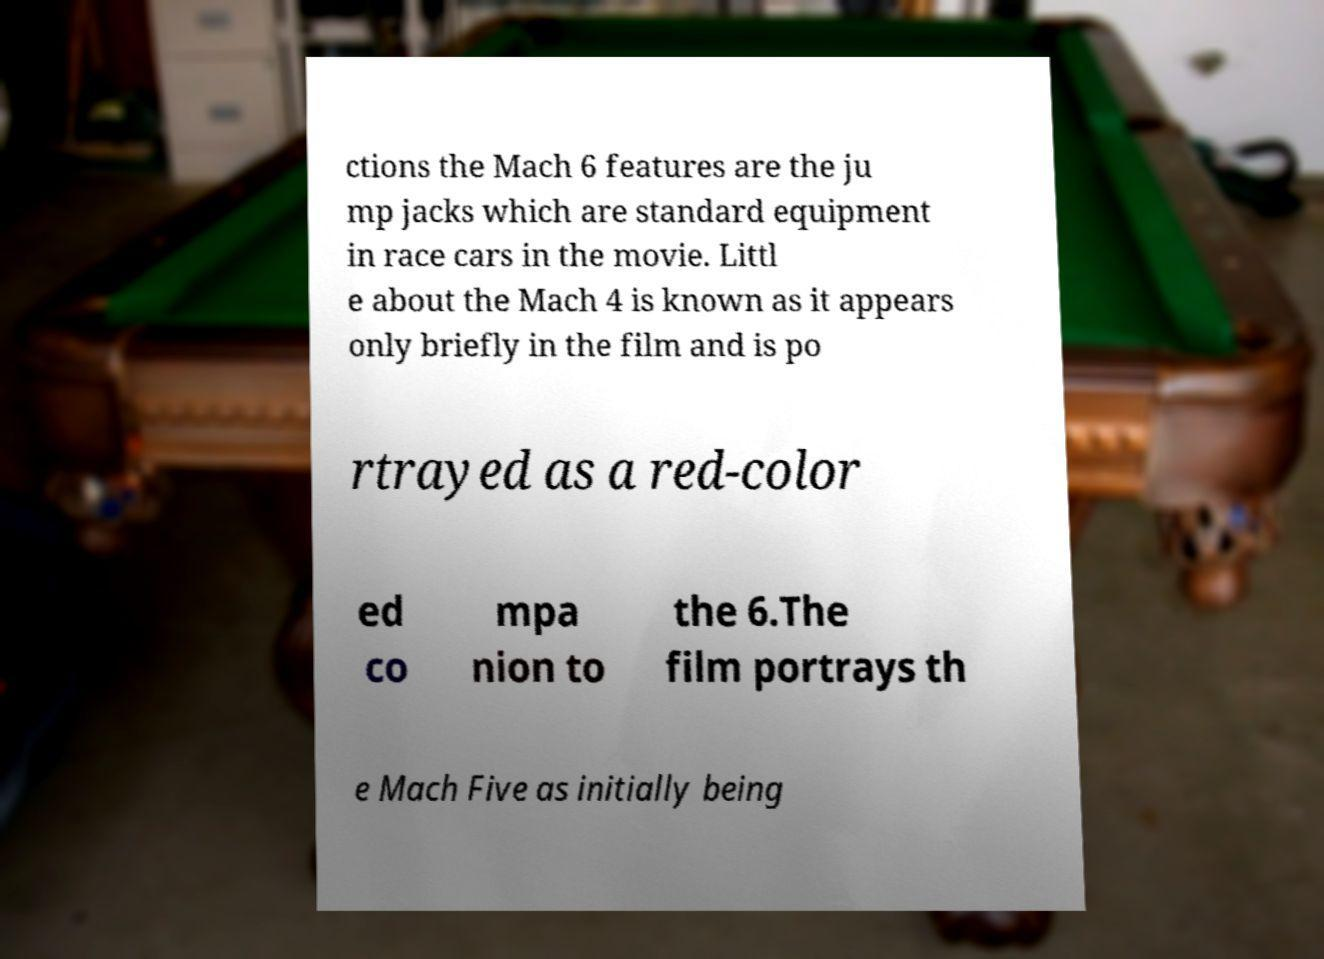What messages or text are displayed in this image? I need them in a readable, typed format. ctions the Mach 6 features are the ju mp jacks which are standard equipment in race cars in the movie. Littl e about the Mach 4 is known as it appears only briefly in the film and is po rtrayed as a red-color ed co mpa nion to the 6.The film portrays th e Mach Five as initially being 